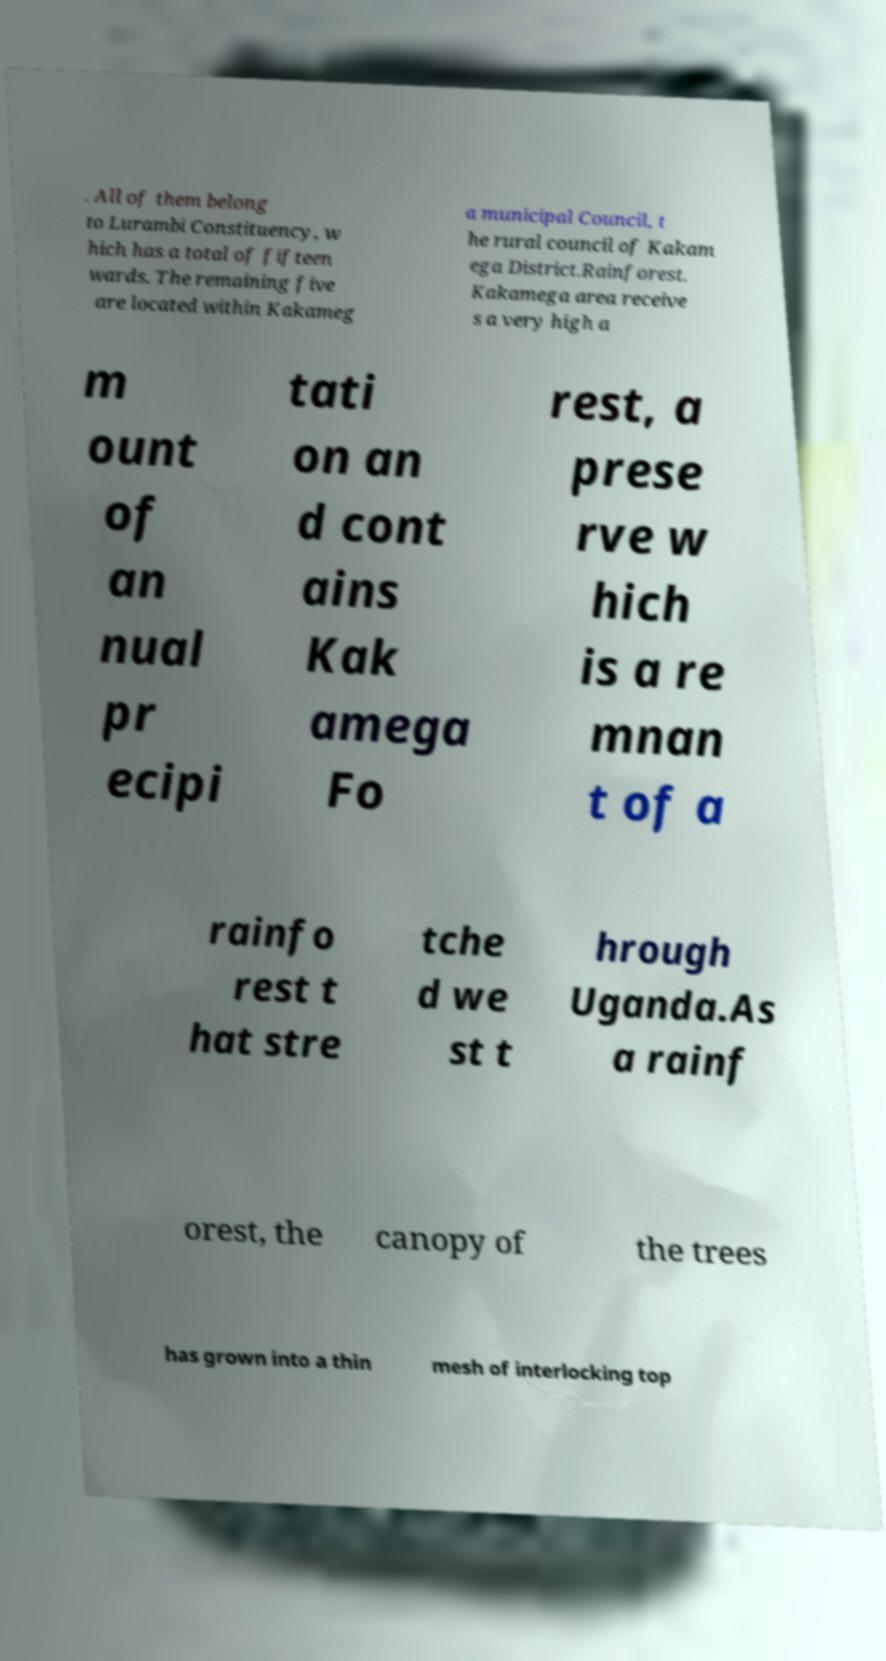Could you assist in decoding the text presented in this image and type it out clearly? . All of them belong to Lurambi Constituency, w hich has a total of fifteen wards. The remaining five are located within Kakameg a municipal Council, t he rural council of Kakam ega District.Rainforest. Kakamega area receive s a very high a m ount of an nual pr ecipi tati on an d cont ains Kak amega Fo rest, a prese rve w hich is a re mnan t of a rainfo rest t hat stre tche d we st t hrough Uganda.As a rainf orest, the canopy of the trees has grown into a thin mesh of interlocking top 